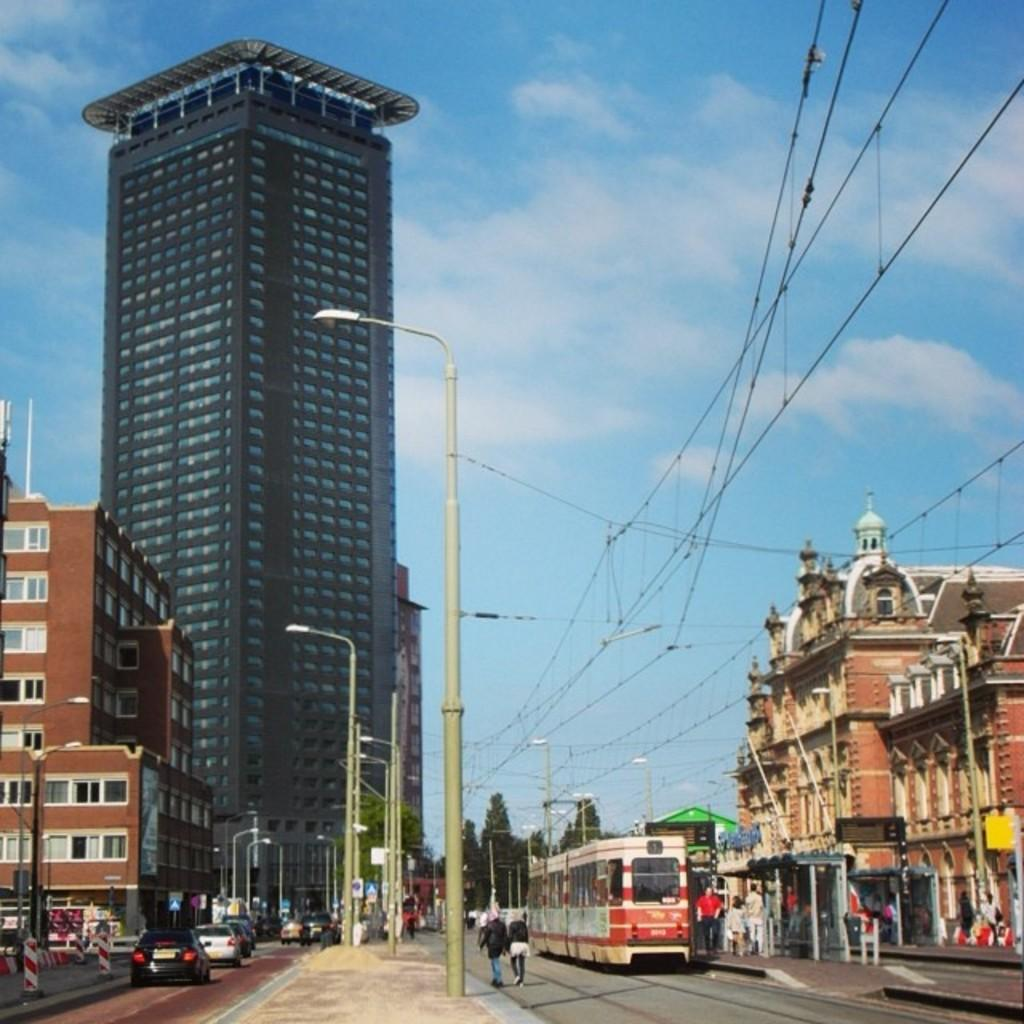What type of vehicles can be seen in the image? There are cars in the image. What other structures are present in the image? There are poles and a train in the image. Are there any living beings in the image? Yes, there are people in the image. What can be seen in the background of the image? Trees, buildings, and the sky are visible in the background of the image. Can you tell me how much poison is being exchanged between the people in the image? There is no mention of poison or any exchange of it in the image. What type of waves can be seen in the image? There are no waves present in the image. 